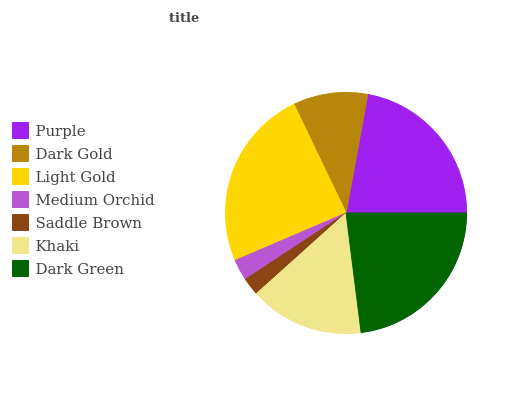Is Saddle Brown the minimum?
Answer yes or no. Yes. Is Light Gold the maximum?
Answer yes or no. Yes. Is Dark Gold the minimum?
Answer yes or no. No. Is Dark Gold the maximum?
Answer yes or no. No. Is Purple greater than Dark Gold?
Answer yes or no. Yes. Is Dark Gold less than Purple?
Answer yes or no. Yes. Is Dark Gold greater than Purple?
Answer yes or no. No. Is Purple less than Dark Gold?
Answer yes or no. No. Is Khaki the high median?
Answer yes or no. Yes. Is Khaki the low median?
Answer yes or no. Yes. Is Light Gold the high median?
Answer yes or no. No. Is Dark Gold the low median?
Answer yes or no. No. 